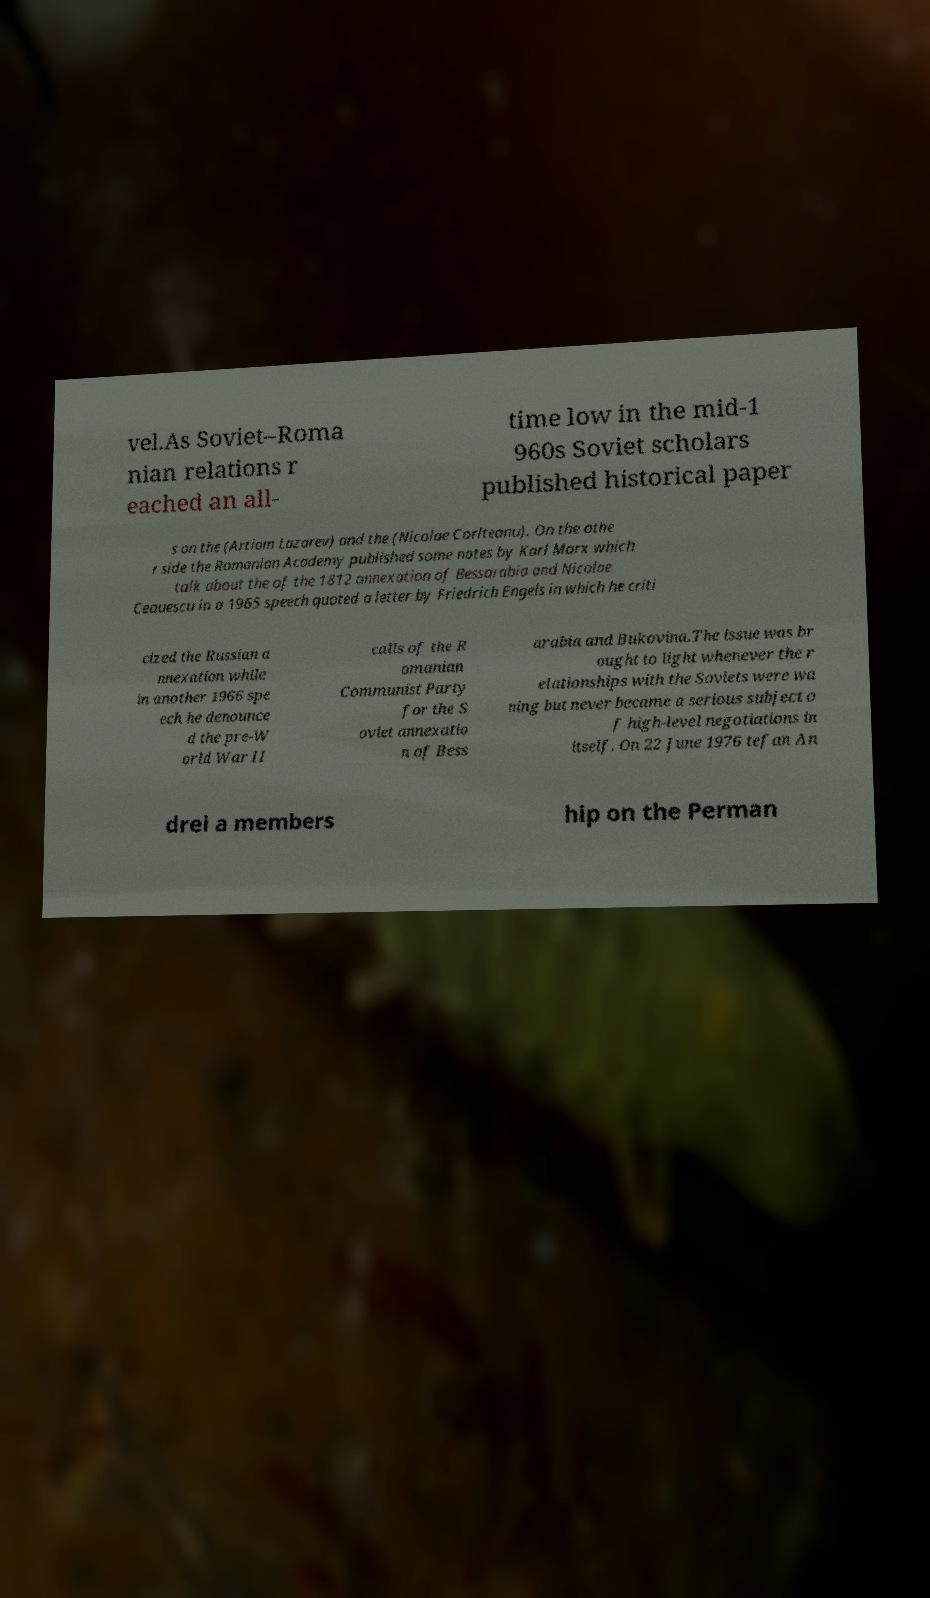Please identify and transcribe the text found in this image. vel.As Soviet–Roma nian relations r eached an all- time low in the mid-1 960s Soviet scholars published historical paper s on the (Artiom Lazarev) and the (Nicolae Corlteanu). On the othe r side the Romanian Academy published some notes by Karl Marx which talk about the of the 1812 annexation of Bessarabia and Nicolae Ceauescu in a 1965 speech quoted a letter by Friedrich Engels in which he criti cized the Russian a nnexation while in another 1966 spe ech he denounce d the pre-W orld War II calls of the R omanian Communist Party for the S oviet annexatio n of Bess arabia and Bukovina.The issue was br ought to light whenever the r elationships with the Soviets were wa ning but never became a serious subject o f high-level negotiations in itself. On 22 June 1976 tefan An drei a members hip on the Perman 